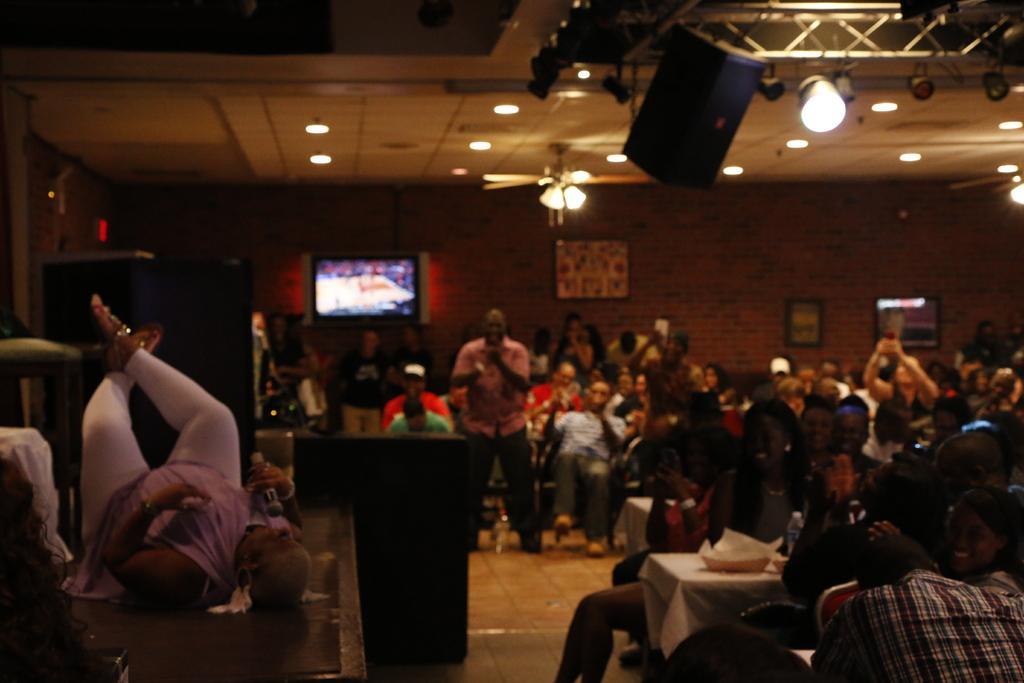In one or two sentences, can you explain what this image depicts? In this picture we can see a group of people were some are sitting on chairs and some are standing and in front of them we can see a person holding a mic and lying on a platform, tables, lights, screen, papers, speakers, frames on the wall and some objects. 